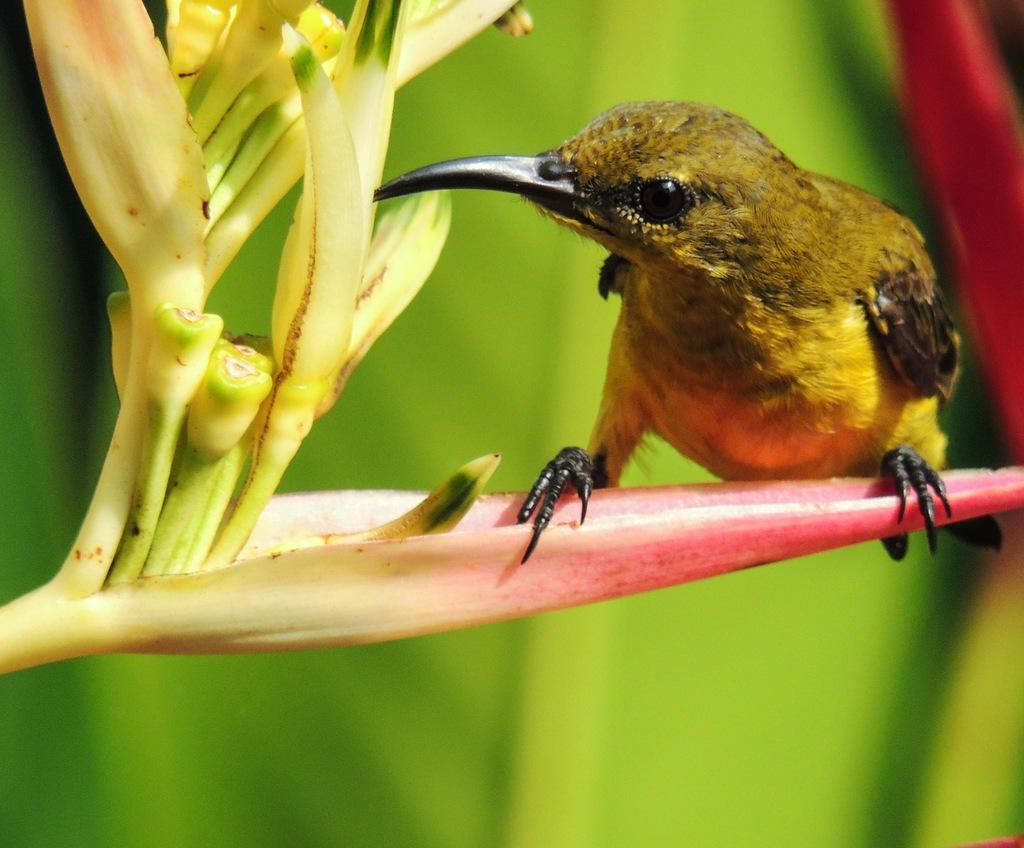What type of animal can be seen in the image? There is a bird in the image. Where is the bird located in the image? The bird is on a flower. What type of leg is the bird using to play baseball in the image? There is no baseball or leg present in the image; it only features a bird on a flower. 